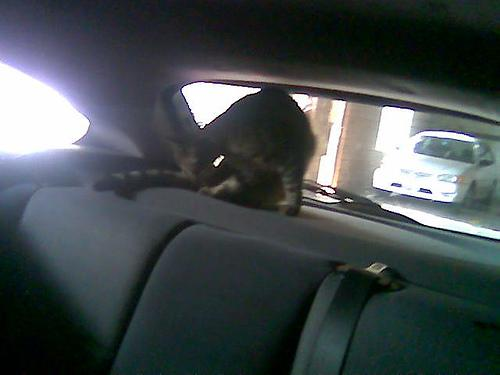Question: what is the color of wall posts?
Choices:
A. White.
B. Black.
C. Red.
D. Purple.
Answer with the letter. Answer: C Question: who is in the picture?
Choices:
A. Mom.
B. Dad.
C. Cat.
D. Sister.
Answer with the letter. Answer: C Question: what color are seats in car?
Choices:
A. White.
B. Red.
C. Black.
D. Grey.
Answer with the letter. Answer: D 